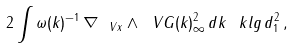Convert formula to latex. <formula><loc_0><loc_0><loc_500><loc_500>2 \int \omega ( k ) ^ { - 1 } \, \| \nabla _ { \ V { x } } \wedge \ V { G } ( k ) \| ^ { 2 } _ { \infty } \, d k \, \ k l g \, d _ { 1 } ^ { 2 } \, ,</formula> 